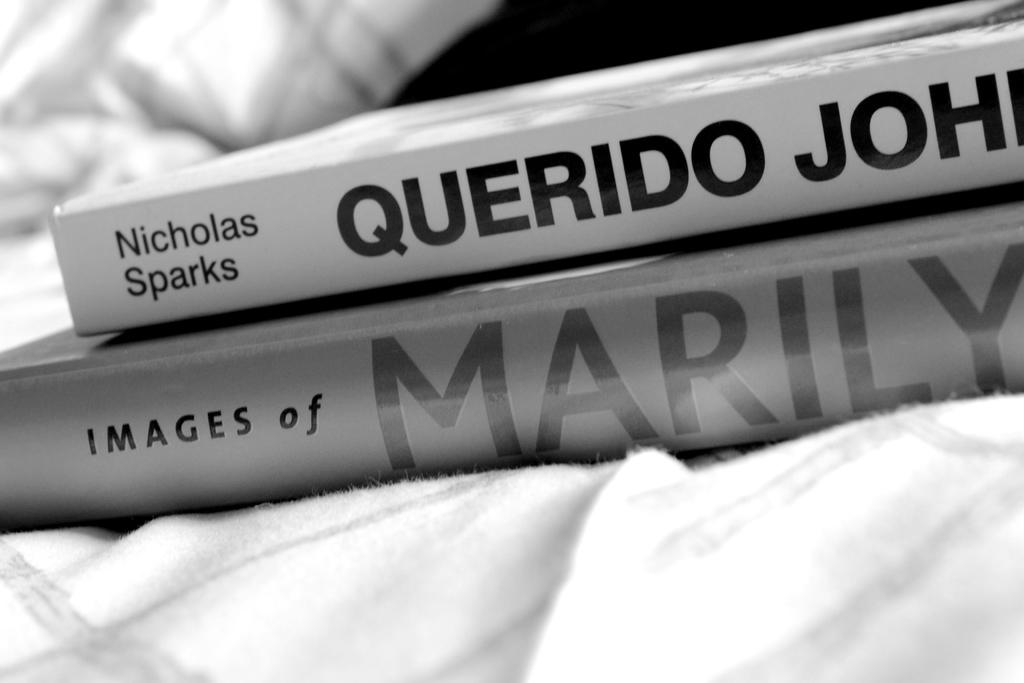Provide a one-sentence caption for the provided image. A pile of two books in black and white with one book titled Querido John by Nicholas Sparks and the bottom book is titled Images of Marilyn. 